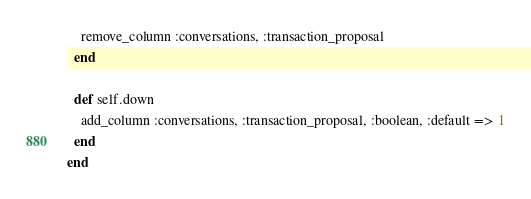Convert code to text. <code><loc_0><loc_0><loc_500><loc_500><_Ruby_>    remove_column :conversations, :transaction_proposal
  end

  def self.down
    add_column :conversations, :transaction_proposal, :boolean, :default => 1
  end
end
</code> 